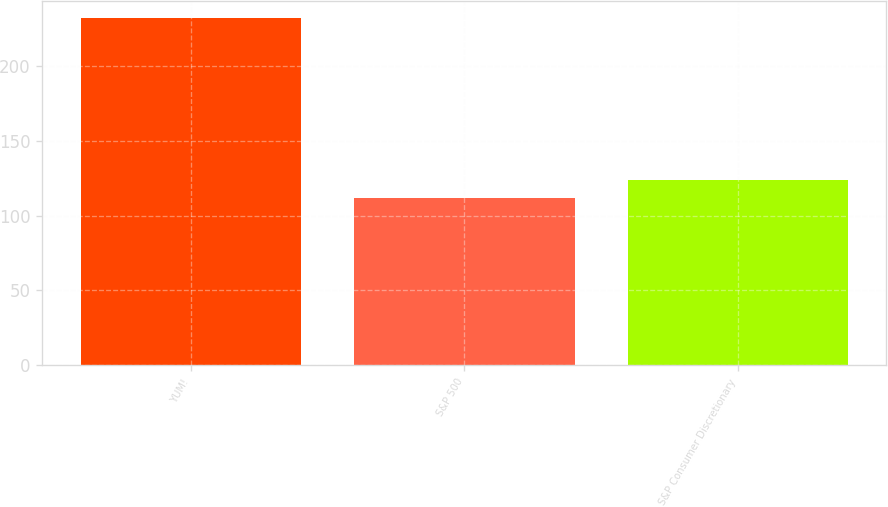Convert chart. <chart><loc_0><loc_0><loc_500><loc_500><bar_chart><fcel>YUM!<fcel>S&P 500<fcel>S&P Consumer Discretionary<nl><fcel>232<fcel>112<fcel>124<nl></chart> 